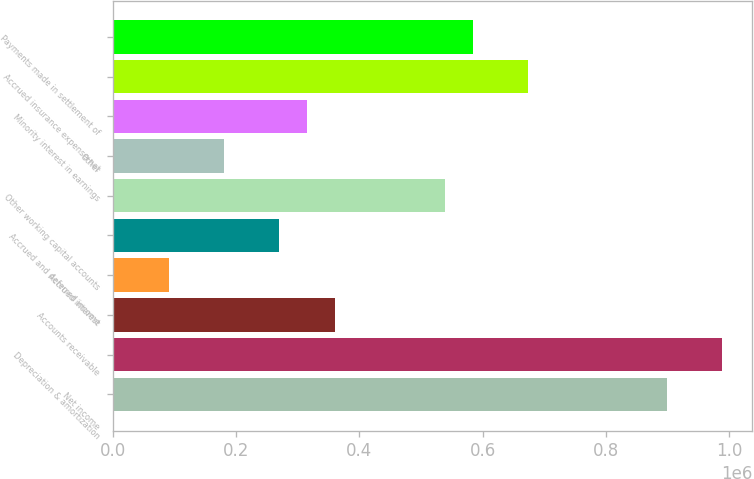Convert chart. <chart><loc_0><loc_0><loc_500><loc_500><bar_chart><fcel>Net income<fcel>Depreciation & amortization<fcel>Accounts receivable<fcel>Accrued interest<fcel>Accrued and deferred income<fcel>Other working capital accounts<fcel>Other<fcel>Minority interest in earnings<fcel>Accrued insurance expense net<fcel>Payments made in settlement of<nl><fcel>898510<fcel>988302<fcel>359757<fcel>90380.2<fcel>269965<fcel>539341<fcel>180172<fcel>314861<fcel>674030<fcel>584237<nl></chart> 